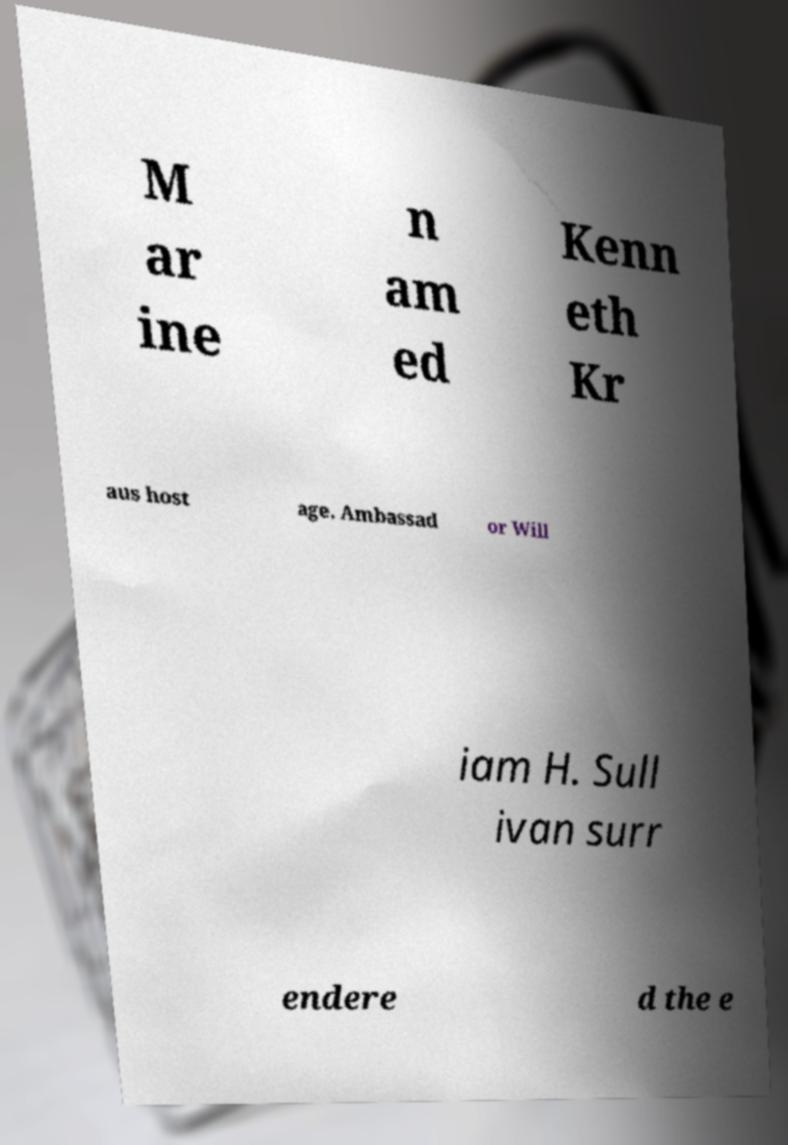Can you accurately transcribe the text from the provided image for me? M ar ine n am ed Kenn eth Kr aus host age. Ambassad or Will iam H. Sull ivan surr endere d the e 